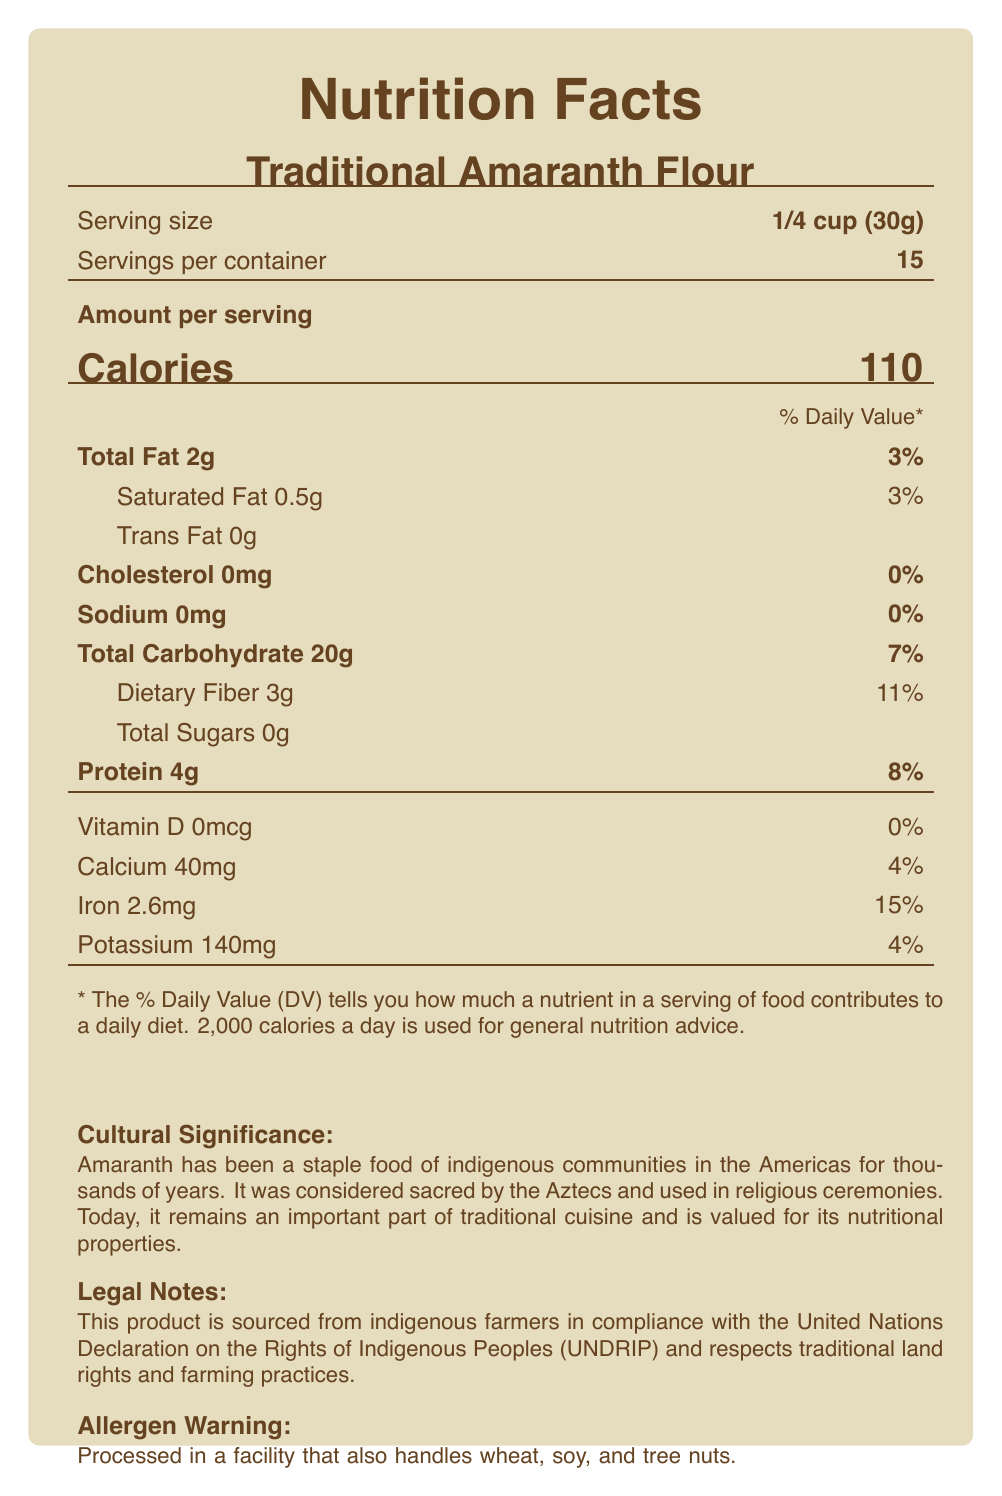what is the serving size? The serving size is mentioned right after the product name at the top of the nutrition facts section.
Answer: 1/4 cup (30g) what is the amount of dietary fiber per serving? Under the Total Carbohydrate section, it lists Dietary Fiber as 3g.
Answer: 3g which vitamin does this product contain in the least amount? A. Vitamin D B. Calcium C. Iron D. Potassium The document shows that Vitamin D is 0mcg, which is the least amount compared to the other vitamins and minerals listed.
Answer: A is this product high in iron? The product contains 2.6mg of iron, which is 15% of the daily value, indicating it is relatively high in iron.
Answer: Yes how many servings are in the container? The document states that there are 15 servings per container.
Answer: 15 how many calories are in one serving of this product? The calories per serving are listed as 110 in the Amount per serving section.
Answer: 110 what is the percentage of daily value for calcium? The percentage of daily value for calcium is listed as 4% under the Vitamin and Mineral section.
Answer: 4% what is the total amount of sugars per serving? The document lists Total Sugars as 0g.
Answer: 0g when was amaranth considered sacred by the Aztecs? A. Thousands of years ago B. Hundreds of years ago C. During colonial times D. In the 20th century The cultural significance note states that amaranth has been a staple food of indigenous communities in the Americas for thousands of years and was considered sacred by the Aztecs.
Answer: A is this product processed in a facility that handles wheat? Yes/No The allergen warning states that it is processed in a facility that also handles wheat.
Answer: Yes what is the main idea of this document? The document highlights the nutritional details of the product, its cultural importance to indigenous communities, its legal compliance and sustainability, and allergen information.
Answer: The document provides the nutrition facts for Traditional Amaranth Flour, emphasizing its cultural and legal significance, nutritional value, and sustainability. who are the farmers that produce this product? The document mentions that the product is sourced from indigenous farmers but does not provide specific details about them.
Answer: Not enough information 